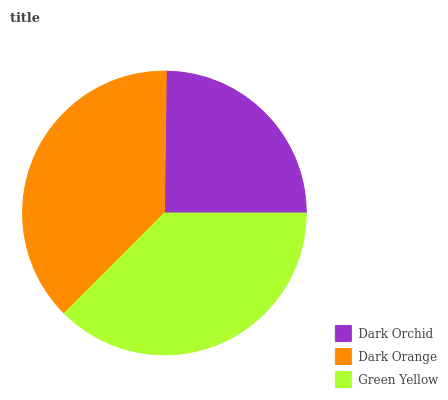Is Dark Orchid the minimum?
Answer yes or no. Yes. Is Dark Orange the maximum?
Answer yes or no. Yes. Is Green Yellow the minimum?
Answer yes or no. No. Is Green Yellow the maximum?
Answer yes or no. No. Is Dark Orange greater than Green Yellow?
Answer yes or no. Yes. Is Green Yellow less than Dark Orange?
Answer yes or no. Yes. Is Green Yellow greater than Dark Orange?
Answer yes or no. No. Is Dark Orange less than Green Yellow?
Answer yes or no. No. Is Green Yellow the high median?
Answer yes or no. Yes. Is Green Yellow the low median?
Answer yes or no. Yes. Is Dark Orchid the high median?
Answer yes or no. No. Is Dark Orange the low median?
Answer yes or no. No. 